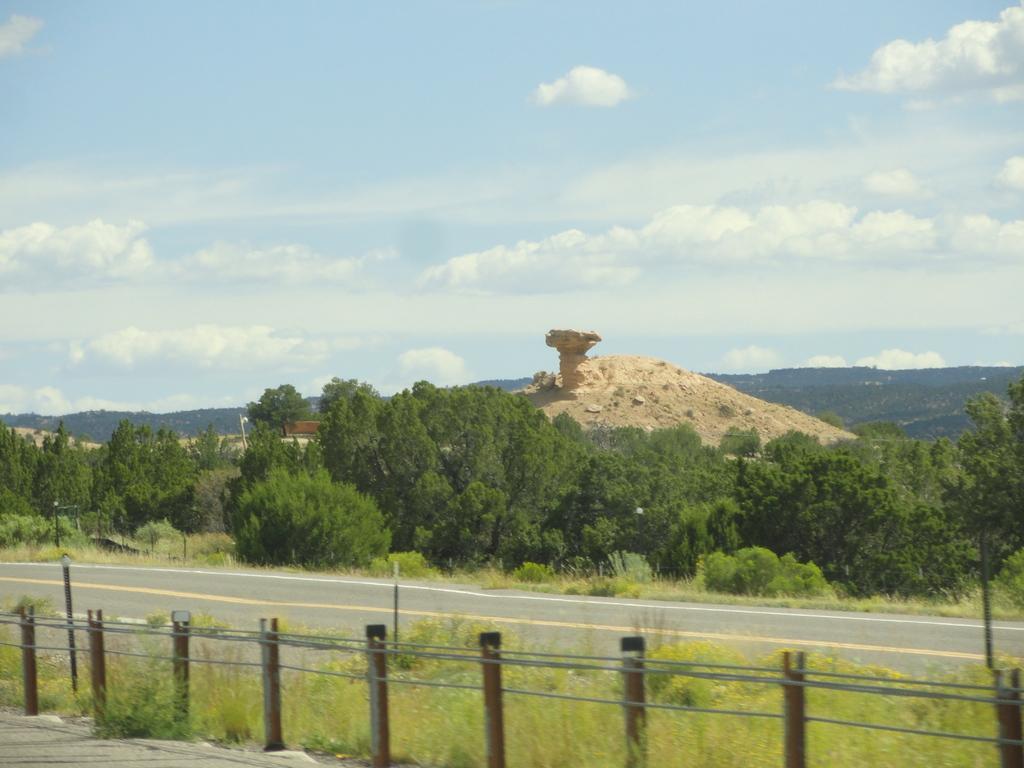Can you describe this image briefly? In this picture we can see a fence, road, plants, trees, mountains, soil and some objects and in the background we can see the sky with clouds. 